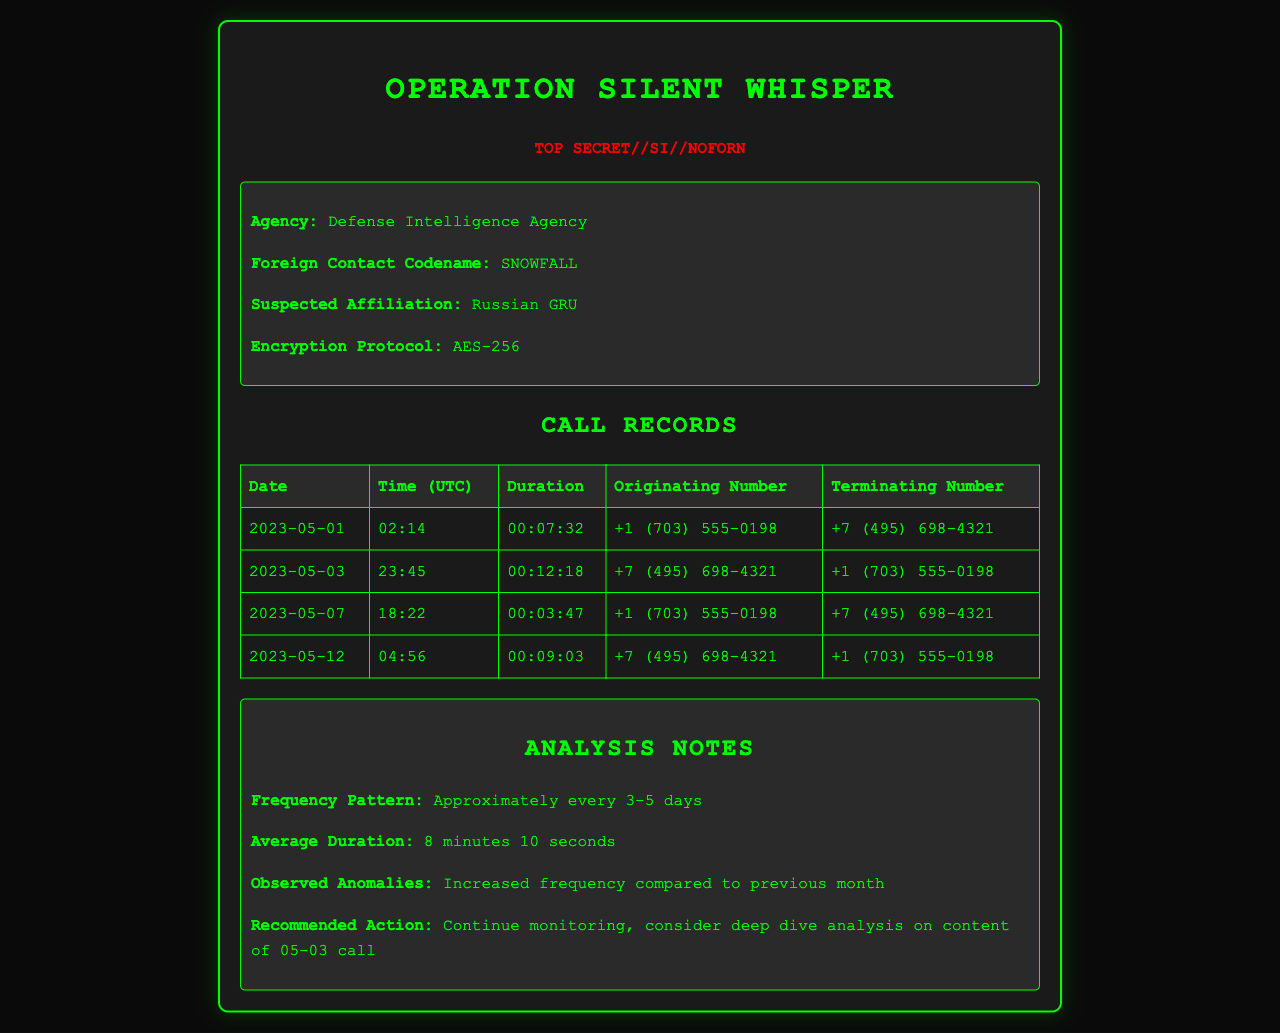what is the name of the operation? The title of the operation is prominently displayed at the top of the document.
Answer: Operation SILENT WHISPER what is the suspected affiliation of the foreign contact? The document specifies the suspected affiliation in the foreign contact information block.
Answer: Russian GRU how many calls were made on 2023-05-01? The call records table lists a single entry for this date.
Answer: 1 what is the average duration of the calls? The analysis notes section provides insights into the average duration calculated from the call records.
Answer: 8 minutes 10 seconds what was the duration of the call on 2023-05-12? The call records table displays the duration for each specific call made on this date.
Answer: 00:09:03 which encryption protocol was used? The encryption protocol used is listed under the foreign contact information.
Answer: AES-256 how many calls were recorded in total? By counting the entries in the call records table, one can determine the total number of calls.
Answer: 4 when was the last recorded call before the analysis? The last recorded call can be identified by looking at the dates in the call records table.
Answer: 2023-05-12 what is the recommended action from the analysis notes? The analysis notes provide a specific recommended action based on observed patterns in the calls.
Answer: Continue monitoring, consider deep dive analysis on content of 05-03 call 